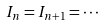Convert formula to latex. <formula><loc_0><loc_0><loc_500><loc_500>I _ { n } = I _ { n + 1 } = \cdot \cdot \cdot</formula> 